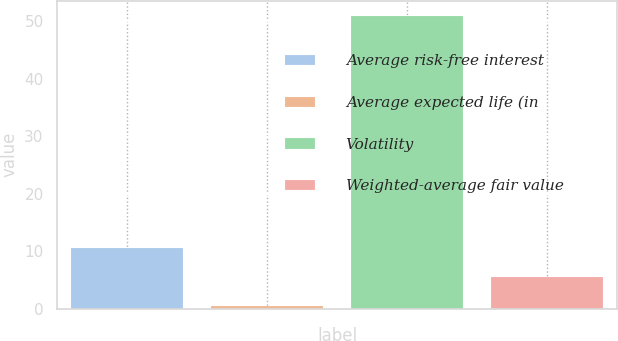<chart> <loc_0><loc_0><loc_500><loc_500><bar_chart><fcel>Average risk-free interest<fcel>Average expected life (in<fcel>Volatility<fcel>Weighted-average fair value<nl><fcel>10.6<fcel>0.5<fcel>51<fcel>5.55<nl></chart> 